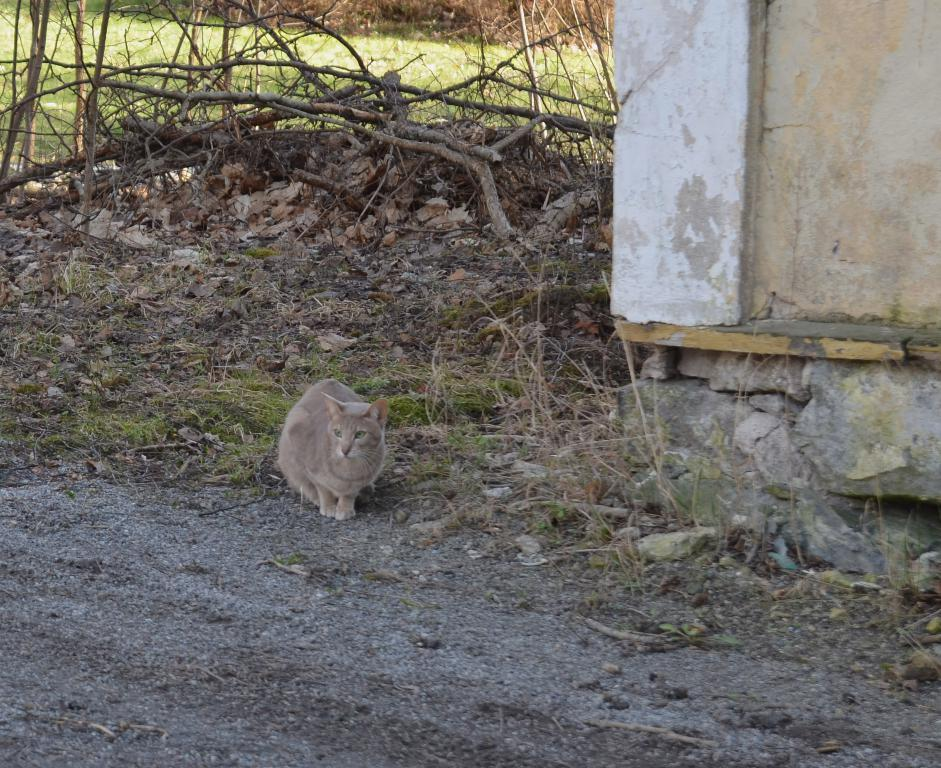What type of animal is in the image? There is a brown cat in the image. Where is the cat located in the image? The cat is sitting on the ground. What can be seen in the background of the image? There are dry leaves and tree branches in the image. What is on the left side of the image? There is a white wall and stones on the left side of the image. Can you tell me how many bears are present in the image? There are no bears present in the image; it features a brown cat. What is the height of the man in the image? There is no man present in the image. 